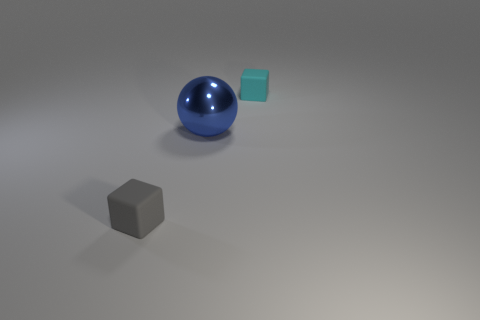Is there a gray cube made of the same material as the small cyan block?
Give a very brief answer. Yes. There is a tiny gray rubber object; is it the same shape as the tiny thing behind the blue shiny sphere?
Your answer should be compact. Yes. What number of small things are both behind the gray thing and to the left of the large blue shiny object?
Offer a very short reply. 0. Is the material of the cyan thing the same as the block that is in front of the blue shiny thing?
Keep it short and to the point. Yes. Are there the same number of small cyan matte blocks on the left side of the big shiny object and tiny red shiny things?
Provide a succinct answer. Yes. The small rubber object on the right side of the big blue metal object is what color?
Provide a succinct answer. Cyan. Are there any other things that are the same size as the gray matte block?
Your answer should be compact. Yes. There is a rubber block behind the gray rubber thing; does it have the same size as the large blue shiny thing?
Make the answer very short. No. What is the blue sphere that is left of the cyan cube made of?
Your answer should be very brief. Metal. Are there any other things that have the same shape as the shiny thing?
Your answer should be compact. No. 